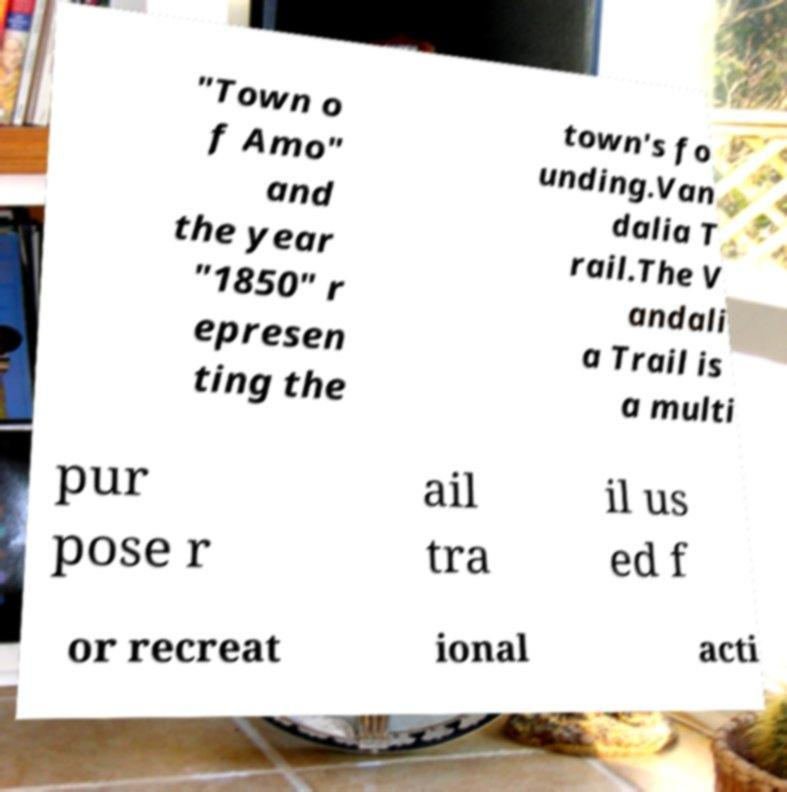There's text embedded in this image that I need extracted. Can you transcribe it verbatim? "Town o f Amo" and the year "1850" r epresen ting the town's fo unding.Van dalia T rail.The V andali a Trail is a multi pur pose r ail tra il us ed f or recreat ional acti 